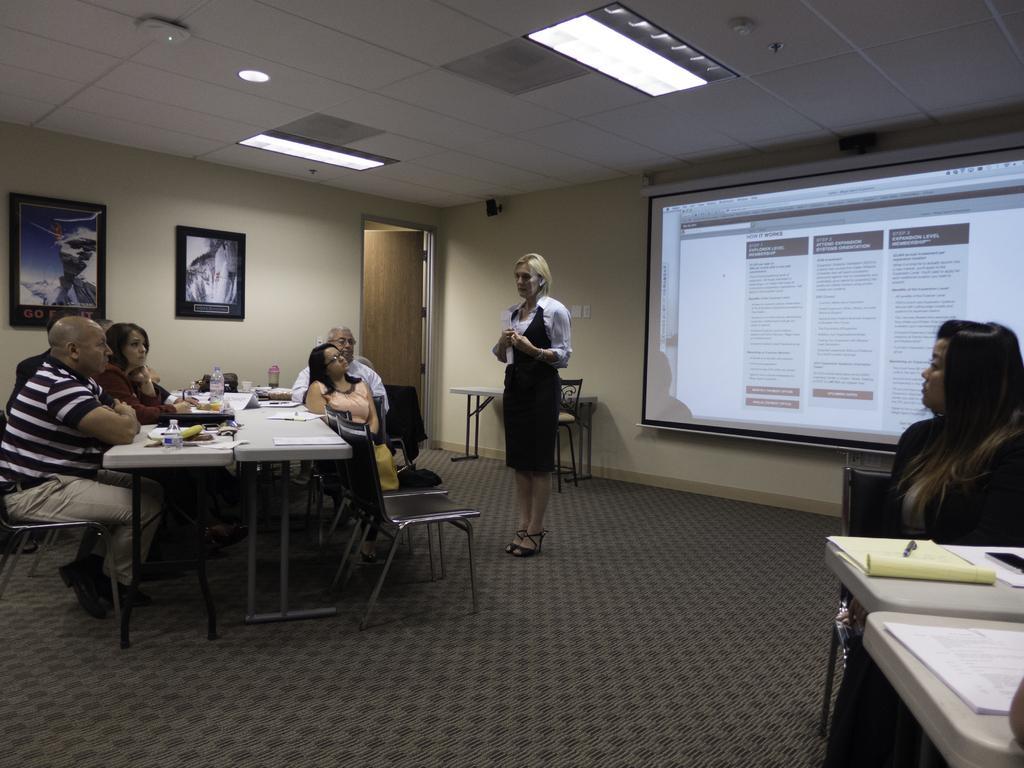Describe this image in one or two sentences. This image taken inside a room. There are few people in this room. In the left side of the image there is a dining table and there are few chairs, few people are sitting around the dining table. In the middle of the image a woman is standing on the floor. In the right side of the image a woman is sitting on the chair and on top of the table there are few things. In the background there is a wall with picture frames, projector screen and a door on it. At the top of the image there is a ceiling with lights. In the bottom of the image there is a floor with mat. 